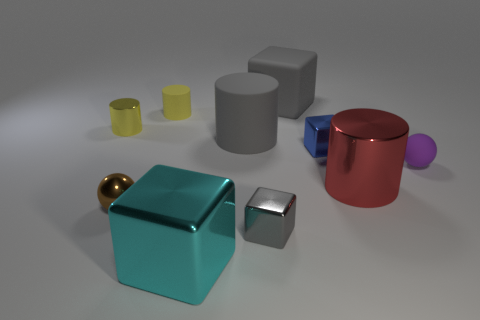Subtract all gray cylinders. How many cylinders are left? 3 Subtract 1 cubes. How many cubes are left? 3 Subtract all blue cubes. How many cubes are left? 3 Subtract all gray balls. How many yellow cylinders are left? 2 Subtract all brown blocks. Subtract all purple balls. How many blocks are left? 4 Add 6 tiny blue things. How many tiny blue things exist? 7 Subtract 2 yellow cylinders. How many objects are left? 8 Subtract all cylinders. How many objects are left? 6 Subtract all large blue rubber blocks. Subtract all matte cylinders. How many objects are left? 8 Add 5 brown shiny objects. How many brown shiny objects are left? 6 